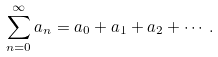Convert formula to latex. <formula><loc_0><loc_0><loc_500><loc_500>\sum _ { n = 0 } ^ { \infty } a _ { n } = a _ { 0 } + a _ { 1 } + a _ { 2 } + \cdots .</formula> 